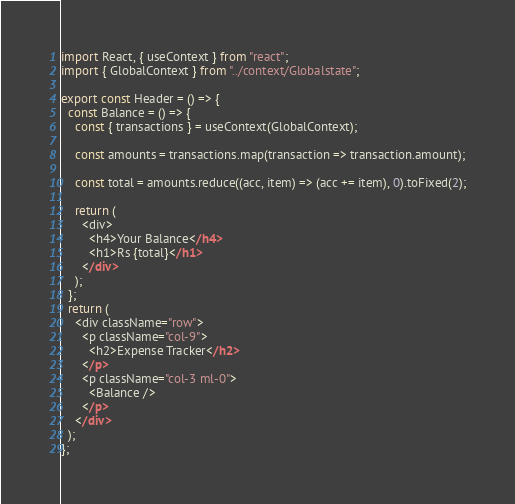<code> <loc_0><loc_0><loc_500><loc_500><_JavaScript_>import React, { useContext } from "react";
import { GlobalContext } from "../context/Globalstate";

export const Header = () => {
  const Balance = () => {
    const { transactions } = useContext(GlobalContext);

    const amounts = transactions.map(transaction => transaction.amount);

    const total = amounts.reduce((acc, item) => (acc += item), 0).toFixed(2);

    return (
      <div>
        <h4>Your Balance</h4>
        <h1>Rs {total}</h1>
      </div>
    );
  };
  return (
    <div className="row">
      <p className="col-9">
        <h2>Expense Tracker</h2>
      </p>
      <p className="col-3 ml-0">
        <Balance />
      </p>
    </div>
  );
};
</code> 